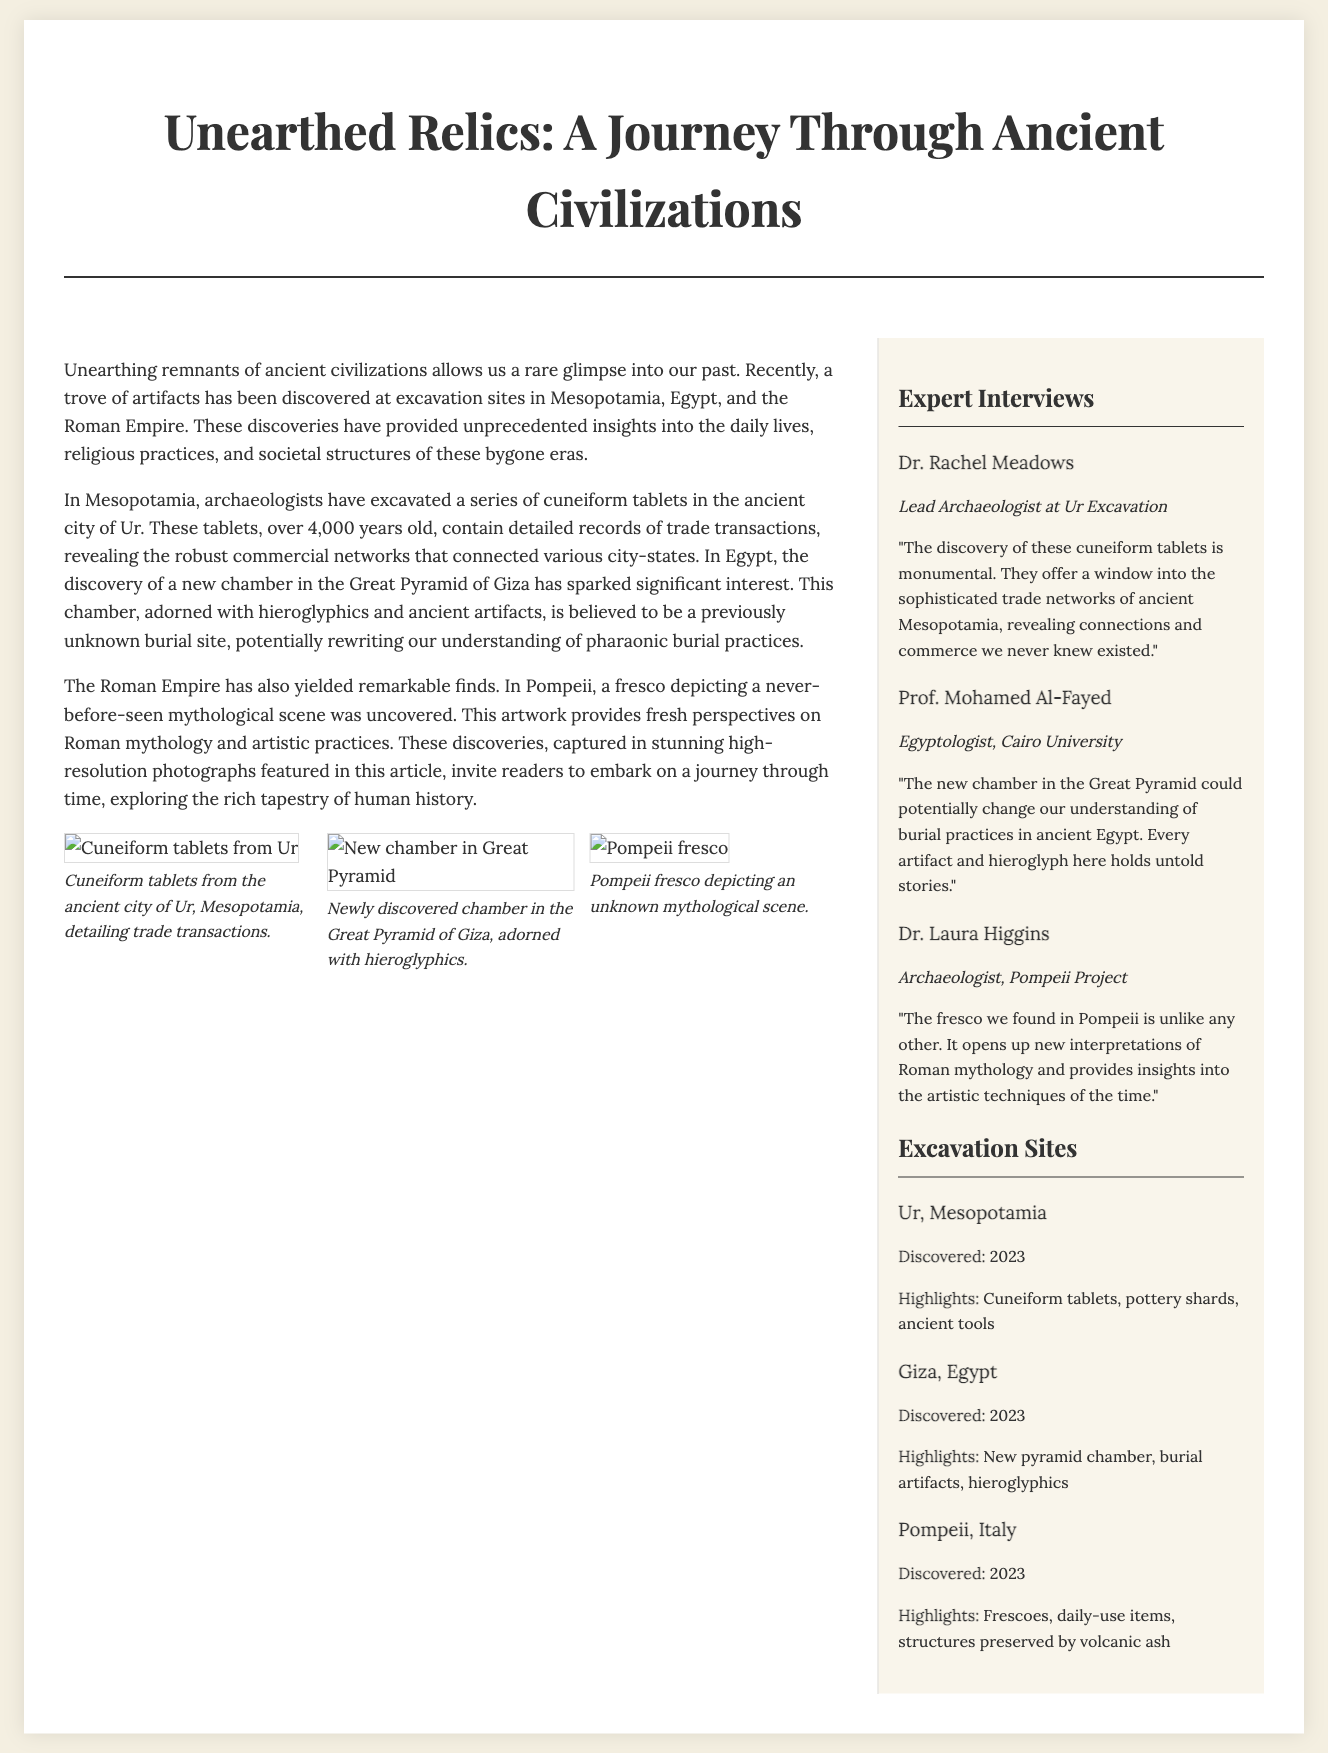What city are the cuneiform tablets from? The cuneiform tablets were discovered in the ancient city of Ur, Mesopotamia.
Answer: Ur What year were the excavation sites discovered? All mentioned excavation sites were discovered in 2023.
Answer: 2023 Who is the lead archaeologist at Ur Excavation? The lead archaeologist at Ur Excavation is Dr. Rachel Meadows.
Answer: Dr. Rachel Meadows What significant finding was made in the Great Pyramid of Giza? A new chamber adorned with hieroglyphics was discovered in the Great Pyramid of Giza.
Answer: New chamber Which ancient civilization provided a fresco depicting a mythological scene? The Roman Empire provided a fresco depicting a never-before-seen mythological scene.
Answer: Roman Empire What type of artifacts were found in Pompeii? Frescoes, daily-use items, and structures preserved by volcanic ash were found in Pompeii.
Answer: Frescoes, daily-use items What does the newly discovered chamber in Giza potentially change? It potentially changes our understanding of burial practices in ancient Egypt.
Answer: Burial practices Why were the cuneiform tablets considered monumental? They are considered monumental because they reveal connections and commerce in ancient Mesopotamia.
Answer: Connections and commerce What is the focus of the interviews in this article? The interviews focus on expert opinions from archaeologists about their findings.
Answer: Expert opinions 